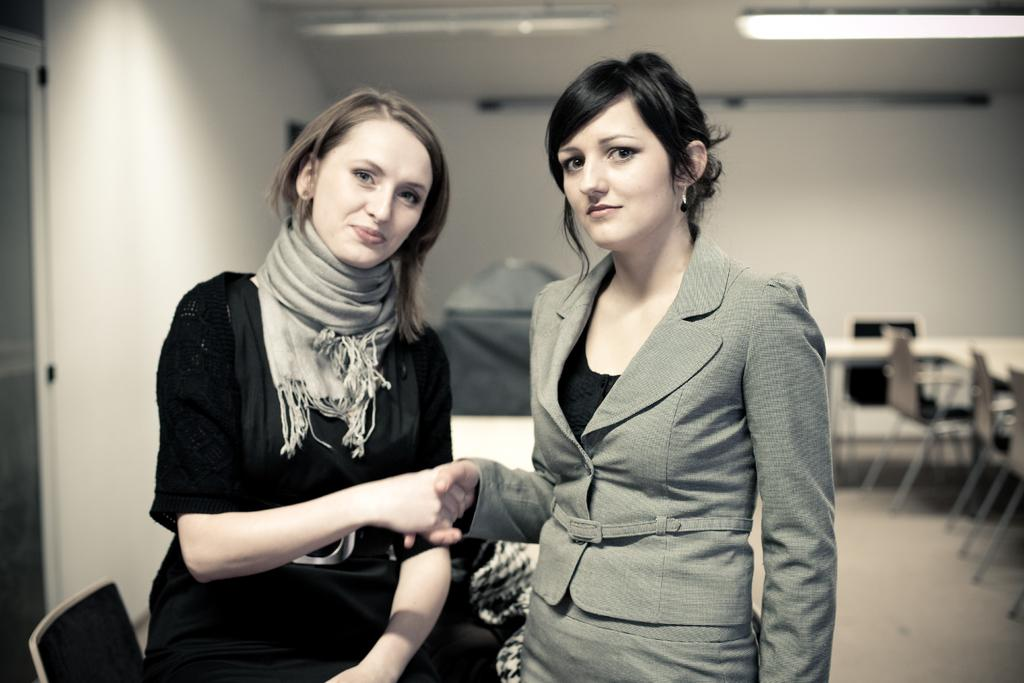What is the main subject on the left side of the image? There is a beautiful woman on the left side of the image. What is the woman on the left side of the image doing? The woman is shaking hands with someone. What color is the dress worn by the woman on the left side of the image? The woman on the left side of the image is wearing a black dress. Can you describe the woman on the right side of the image? There is another woman on the right side of the image, and she is wearing a coat. How does the zephyr affect the woman's feet in the image? There is no mention of a zephyr or any wind in the image, so it cannot affect the woman's feet. What direction does the woman on the right side of the image turn in the image? There is no indication that the woman on the right side of the image is turning in any direction; she is simply standing there wearing a coat. 